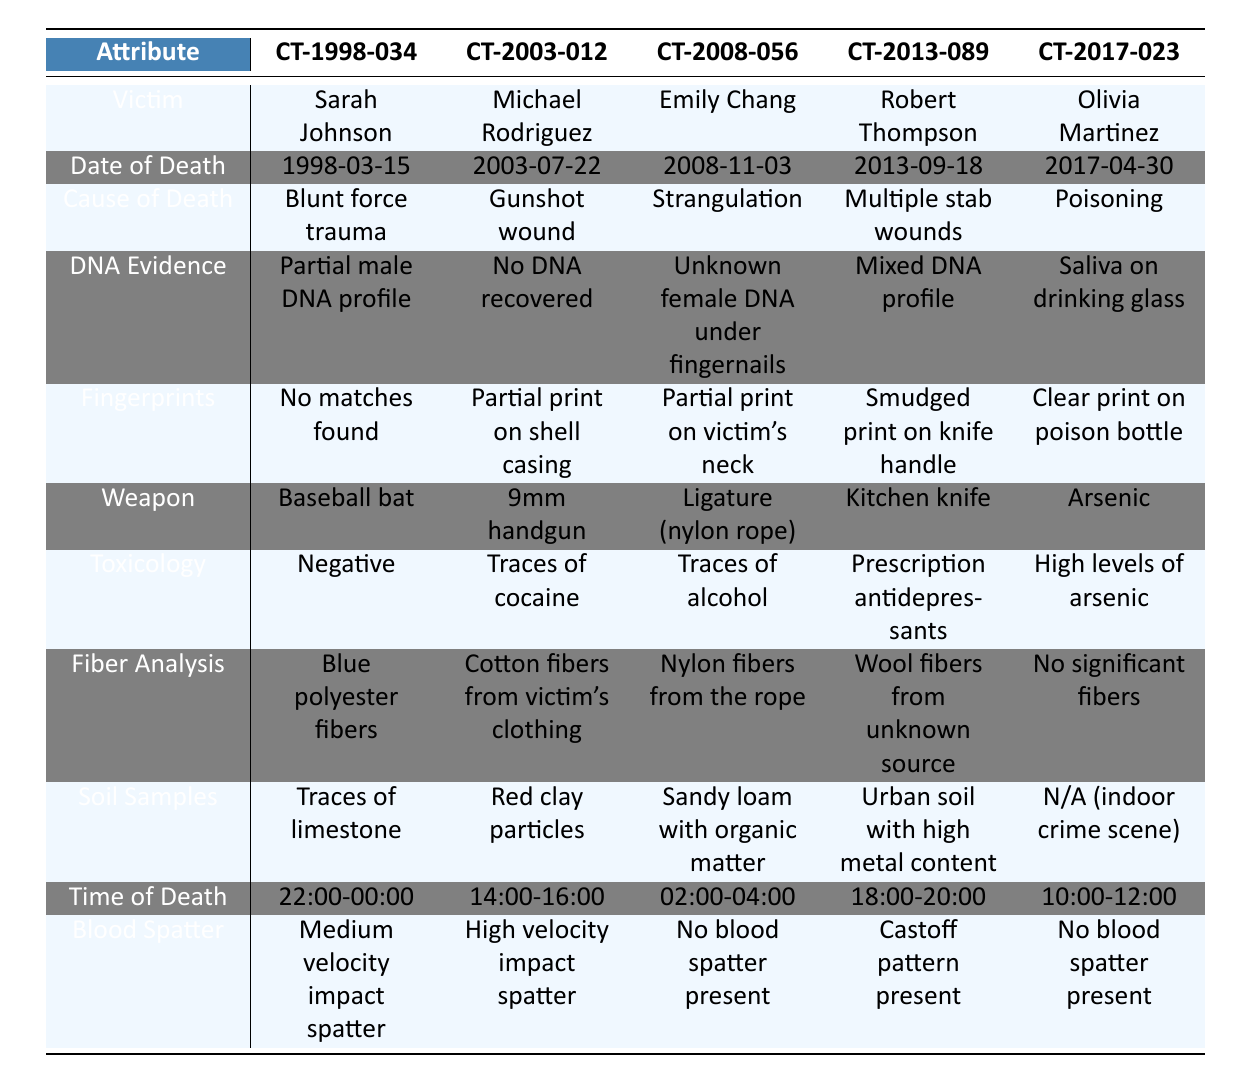What is the cause of death for Sarah Johnson? The table lists the cause of death for Sarah Johnson under her case number CT-1998-034, which is "Blunt force trauma."
Answer: Blunt force trauma Which victim has a partial fingerprint found on a shell casing? Referring to the table, Michael Rodriguez (case number CT-2003-012) has a "Partial print on shell casing" listed in the fingerprints section.
Answer: Michael Rodriguez For which case was DNA evidence recovered? Looking at the DNA evidence column, Sarah Johnson and Olivia Martinez have DNA evidence recovered. Sarah has a "Partial male DNA profile," while Olivia has "Saliva on drinking glass."
Answer: Sarah Johnson and Olivia Martinez Which case involved a weapon of strangulation? In the weapon column, the case for Emily Chang (CT-2008-056) lists "Ligature (nylon rope)" indicating it was a strangulation case.
Answer: Emily Chang Is there any case where the toxicology results were negative? In the toxicology results column, Sarah Johnson's case (CT-1998-034) shows "Negative," confirming that her toxicology results were negative.
Answer: Yes Which victim died from a gunshot wound and had traces of cocaine? Michael Rodriguez (CT-2003-012) is the only victim whose cause of death is a "Gunshot wound" and also shows "Traces of cocaine" in the toxicology results.
Answer: Michael Rodriguez What time frame was the time of death for Robert Thompson? The time of death for Robert Thompson is recorded in the table as "18:00-20:00," indicating he died within that time frame.
Answer: 18:00-20:00 How many cases involved drugs in toxicology results? Referring to the toxicology results column, there are three cases with drug evidence: CT-2003-012 (cocaine), CT-2008-056 (alcohol), and CT-2017-023 (arsenic). Thus, the total is 3 cases.
Answer: 3 cases Which cases have DNA evidence retrieved from the scene? Reviewing the DNA evidence, Sarah Johnson has "Partial male DNA profile," Emily Chang has "Unknown female DNA under fingernails," Robert Thompson has a "Mixed DNA profile," and Olivia Martinez has "Saliva on drinking glass," totaling 4 cases with DNA evidence.
Answer: 4 cases What distinguishes the time of death for the cases involving a firearm versus strangulation? The only case with firearm death is Michael Rodriguez (CT-2003-012), with the time of death "14:00-16:00," while strangulation is represented by Emily Chang (CT-2008-056) with a time of death from "02:00-04:00." Thus, they differ in both the method and the specific time.
Answer: Different method and time intervals 